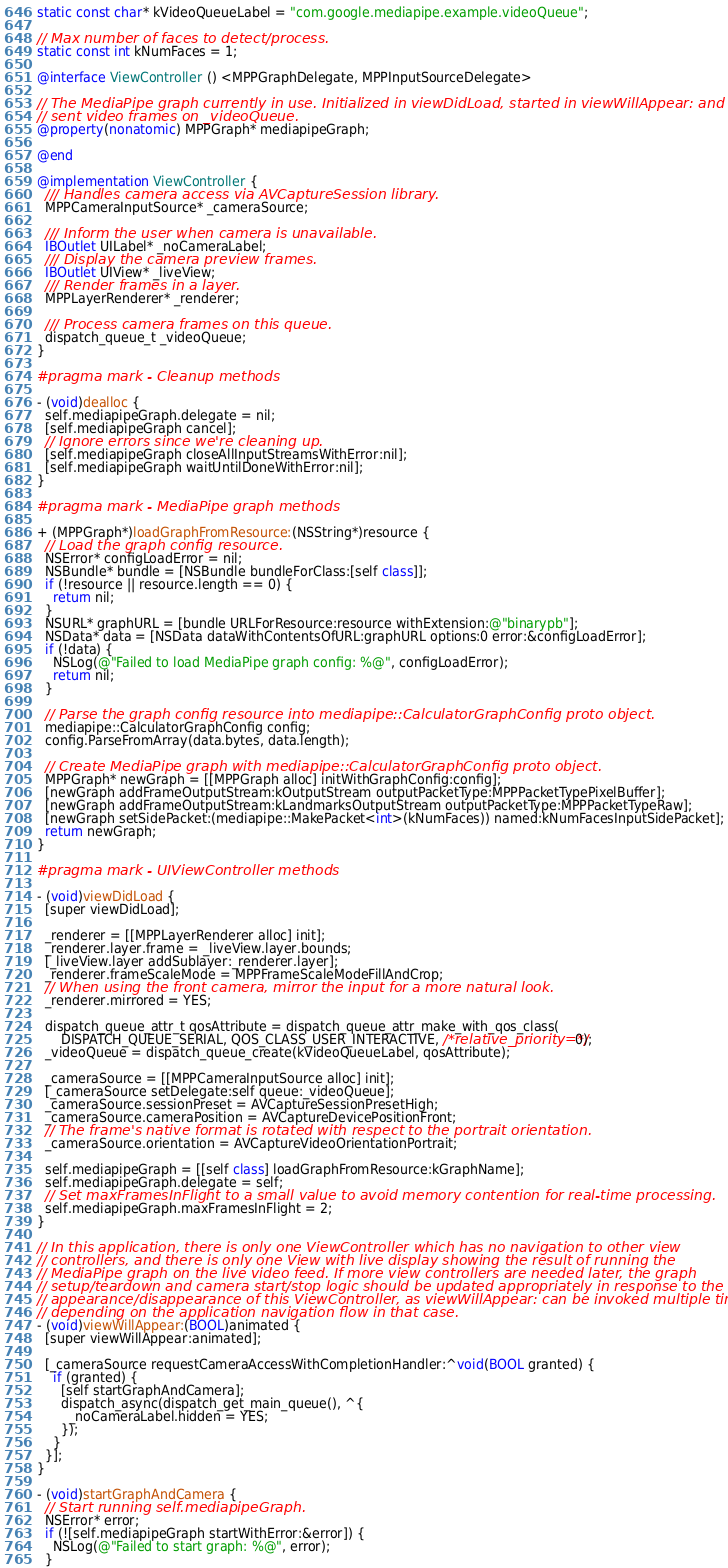<code> <loc_0><loc_0><loc_500><loc_500><_ObjectiveC_>static const char* kVideoQueueLabel = "com.google.mediapipe.example.videoQueue";

// Max number of faces to detect/process.
static const int kNumFaces = 1;

@interface ViewController () <MPPGraphDelegate, MPPInputSourceDelegate>

// The MediaPipe graph currently in use. Initialized in viewDidLoad, started in viewWillAppear: and
// sent video frames on _videoQueue.
@property(nonatomic) MPPGraph* mediapipeGraph;

@end

@implementation ViewController {
  /// Handles camera access via AVCaptureSession library.
  MPPCameraInputSource* _cameraSource;

  /// Inform the user when camera is unavailable.
  IBOutlet UILabel* _noCameraLabel;
  /// Display the camera preview frames.
  IBOutlet UIView* _liveView;
  /// Render frames in a layer.
  MPPLayerRenderer* _renderer;

  /// Process camera frames on this queue.
  dispatch_queue_t _videoQueue;
}

#pragma mark - Cleanup methods

- (void)dealloc {
  self.mediapipeGraph.delegate = nil;
  [self.mediapipeGraph cancel];
  // Ignore errors since we're cleaning up.
  [self.mediapipeGraph closeAllInputStreamsWithError:nil];
  [self.mediapipeGraph waitUntilDoneWithError:nil];
}

#pragma mark - MediaPipe graph methods

+ (MPPGraph*)loadGraphFromResource:(NSString*)resource {
  // Load the graph config resource.
  NSError* configLoadError = nil;
  NSBundle* bundle = [NSBundle bundleForClass:[self class]];
  if (!resource || resource.length == 0) {
    return nil;
  }
  NSURL* graphURL = [bundle URLForResource:resource withExtension:@"binarypb"];
  NSData* data = [NSData dataWithContentsOfURL:graphURL options:0 error:&configLoadError];
  if (!data) {
    NSLog(@"Failed to load MediaPipe graph config: %@", configLoadError);
    return nil;
  }

  // Parse the graph config resource into mediapipe::CalculatorGraphConfig proto object.
  mediapipe::CalculatorGraphConfig config;
  config.ParseFromArray(data.bytes, data.length);

  // Create MediaPipe graph with mediapipe::CalculatorGraphConfig proto object.
  MPPGraph* newGraph = [[MPPGraph alloc] initWithGraphConfig:config];
  [newGraph addFrameOutputStream:kOutputStream outputPacketType:MPPPacketTypePixelBuffer];
  [newGraph addFrameOutputStream:kLandmarksOutputStream outputPacketType:MPPPacketTypeRaw];
  [newGraph setSidePacket:(mediapipe::MakePacket<int>(kNumFaces)) named:kNumFacesInputSidePacket];
  return newGraph;
}

#pragma mark - UIViewController methods

- (void)viewDidLoad {
  [super viewDidLoad];

  _renderer = [[MPPLayerRenderer alloc] init];
  _renderer.layer.frame = _liveView.layer.bounds;
  [_liveView.layer addSublayer:_renderer.layer];
  _renderer.frameScaleMode = MPPFrameScaleModeFillAndCrop;
  // When using the front camera, mirror the input for a more natural look.
  _renderer.mirrored = YES;

  dispatch_queue_attr_t qosAttribute = dispatch_queue_attr_make_with_qos_class(
      DISPATCH_QUEUE_SERIAL, QOS_CLASS_USER_INTERACTIVE, /*relative_priority=*/0);
  _videoQueue = dispatch_queue_create(kVideoQueueLabel, qosAttribute);

  _cameraSource = [[MPPCameraInputSource alloc] init];
  [_cameraSource setDelegate:self queue:_videoQueue];
  _cameraSource.sessionPreset = AVCaptureSessionPresetHigh;
  _cameraSource.cameraPosition = AVCaptureDevicePositionFront;
  // The frame's native format is rotated with respect to the portrait orientation.
  _cameraSource.orientation = AVCaptureVideoOrientationPortrait;

  self.mediapipeGraph = [[self class] loadGraphFromResource:kGraphName];
  self.mediapipeGraph.delegate = self;
  // Set maxFramesInFlight to a small value to avoid memory contention for real-time processing.
  self.mediapipeGraph.maxFramesInFlight = 2;
}

// In this application, there is only one ViewController which has no navigation to other view
// controllers, and there is only one View with live display showing the result of running the
// MediaPipe graph on the live video feed. If more view controllers are needed later, the graph
// setup/teardown and camera start/stop logic should be updated appropriately in response to the
// appearance/disappearance of this ViewController, as viewWillAppear: can be invoked multiple times
// depending on the application navigation flow in that case.
- (void)viewWillAppear:(BOOL)animated {
  [super viewWillAppear:animated];

  [_cameraSource requestCameraAccessWithCompletionHandler:^void(BOOL granted) {
    if (granted) {
      [self startGraphAndCamera];
      dispatch_async(dispatch_get_main_queue(), ^{
        _noCameraLabel.hidden = YES;
      });
    }
  }];
}

- (void)startGraphAndCamera {
  // Start running self.mediapipeGraph.
  NSError* error;
  if (![self.mediapipeGraph startWithError:&error]) {
    NSLog(@"Failed to start graph: %@", error);
  }
</code> 